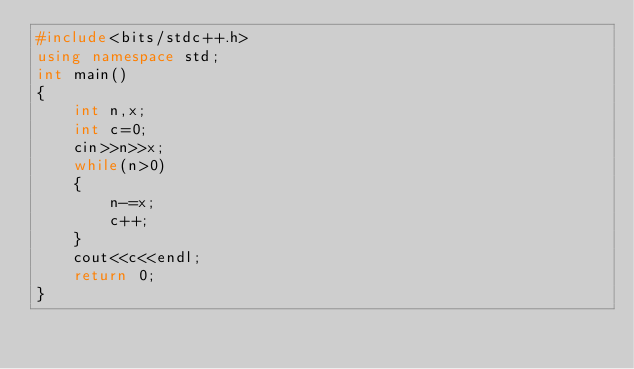Convert code to text. <code><loc_0><loc_0><loc_500><loc_500><_C++_>#include<bits/stdc++.h>
using namespace std;
int main()
{
    int n,x;
    int c=0;
    cin>>n>>x;
    while(n>0)
    {
        n-=x;
        c++;
    }
    cout<<c<<endl;
    return 0;
}
</code> 